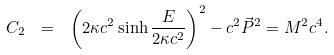Convert formula to latex. <formula><loc_0><loc_0><loc_500><loc_500>C _ { 2 } \ = \ \left ( 2 \kappa c ^ { 2 } \sinh \frac { E } { 2 \kappa c ^ { 2 } } \right ) ^ { 2 } - c ^ { 2 } \vec { P } ^ { 2 } = M ^ { 2 } c ^ { 4 } .</formula> 